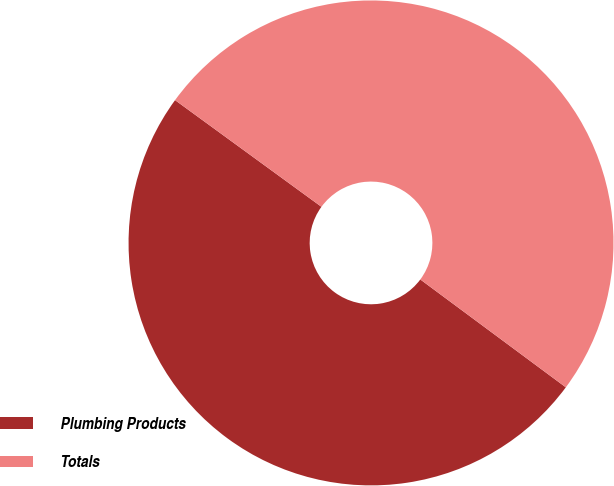Convert chart. <chart><loc_0><loc_0><loc_500><loc_500><pie_chart><fcel>Plumbing Products<fcel>Totals<nl><fcel>49.87%<fcel>50.13%<nl></chart> 